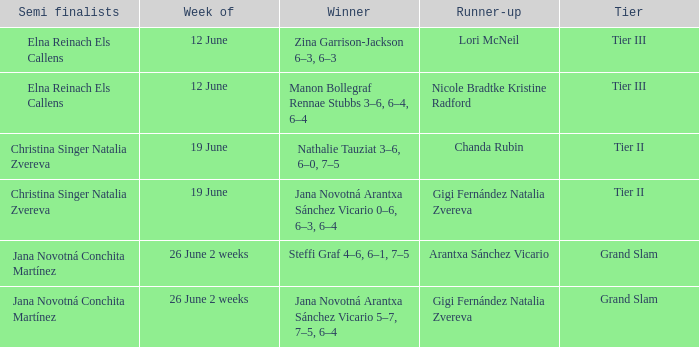When the Tier is listed as tier iii, who is the Winner? Zina Garrison-Jackson 6–3, 6–3, Manon Bollegraf Rennae Stubbs 3–6, 6–4, 6–4. 